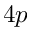Convert formula to latex. <formula><loc_0><loc_0><loc_500><loc_500>4 p</formula> 